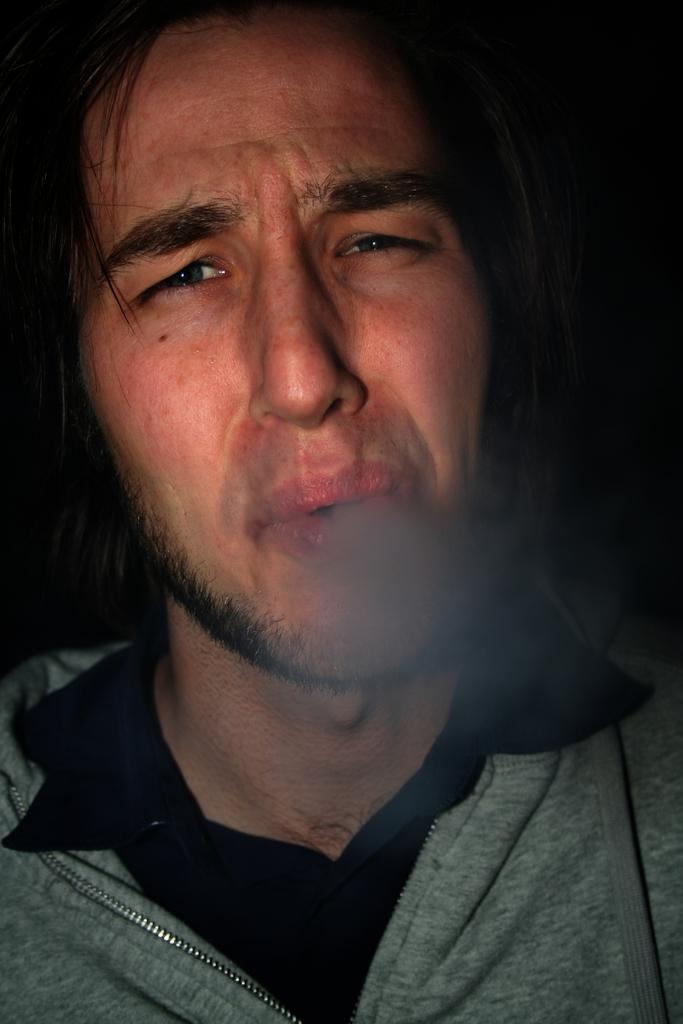What is present in the image? There is a person in the image. What is the person wearing? The person is wearing a sweater and a black shirt. Can you describe the background of the image? The background of the image is dark. What else can be seen in the image? There is smoke visible in the image. What type of boot is the person wearing in the image? There is no boot visible in the image; the person is wearing a sweater and a black shirt. Can you describe the label on the bottle in the image? There is no bottle present in the image; only a person, clothing, smoke, and a dark background are visible. 